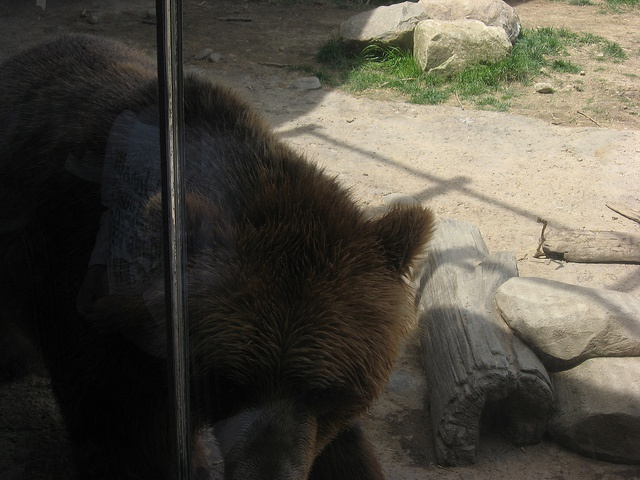Describe the objects in this image and their specific colors. I can see a bear in black and gray tones in this image. 